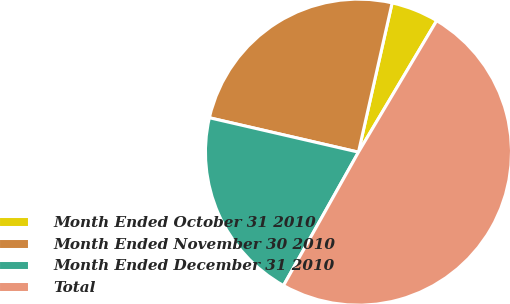Convert chart. <chart><loc_0><loc_0><loc_500><loc_500><pie_chart><fcel>Month Ended October 31 2010<fcel>Month Ended November 30 2010<fcel>Month Ended December 31 2010<fcel>Total<nl><fcel>5.01%<fcel>24.92%<fcel>20.46%<fcel>49.61%<nl></chart> 